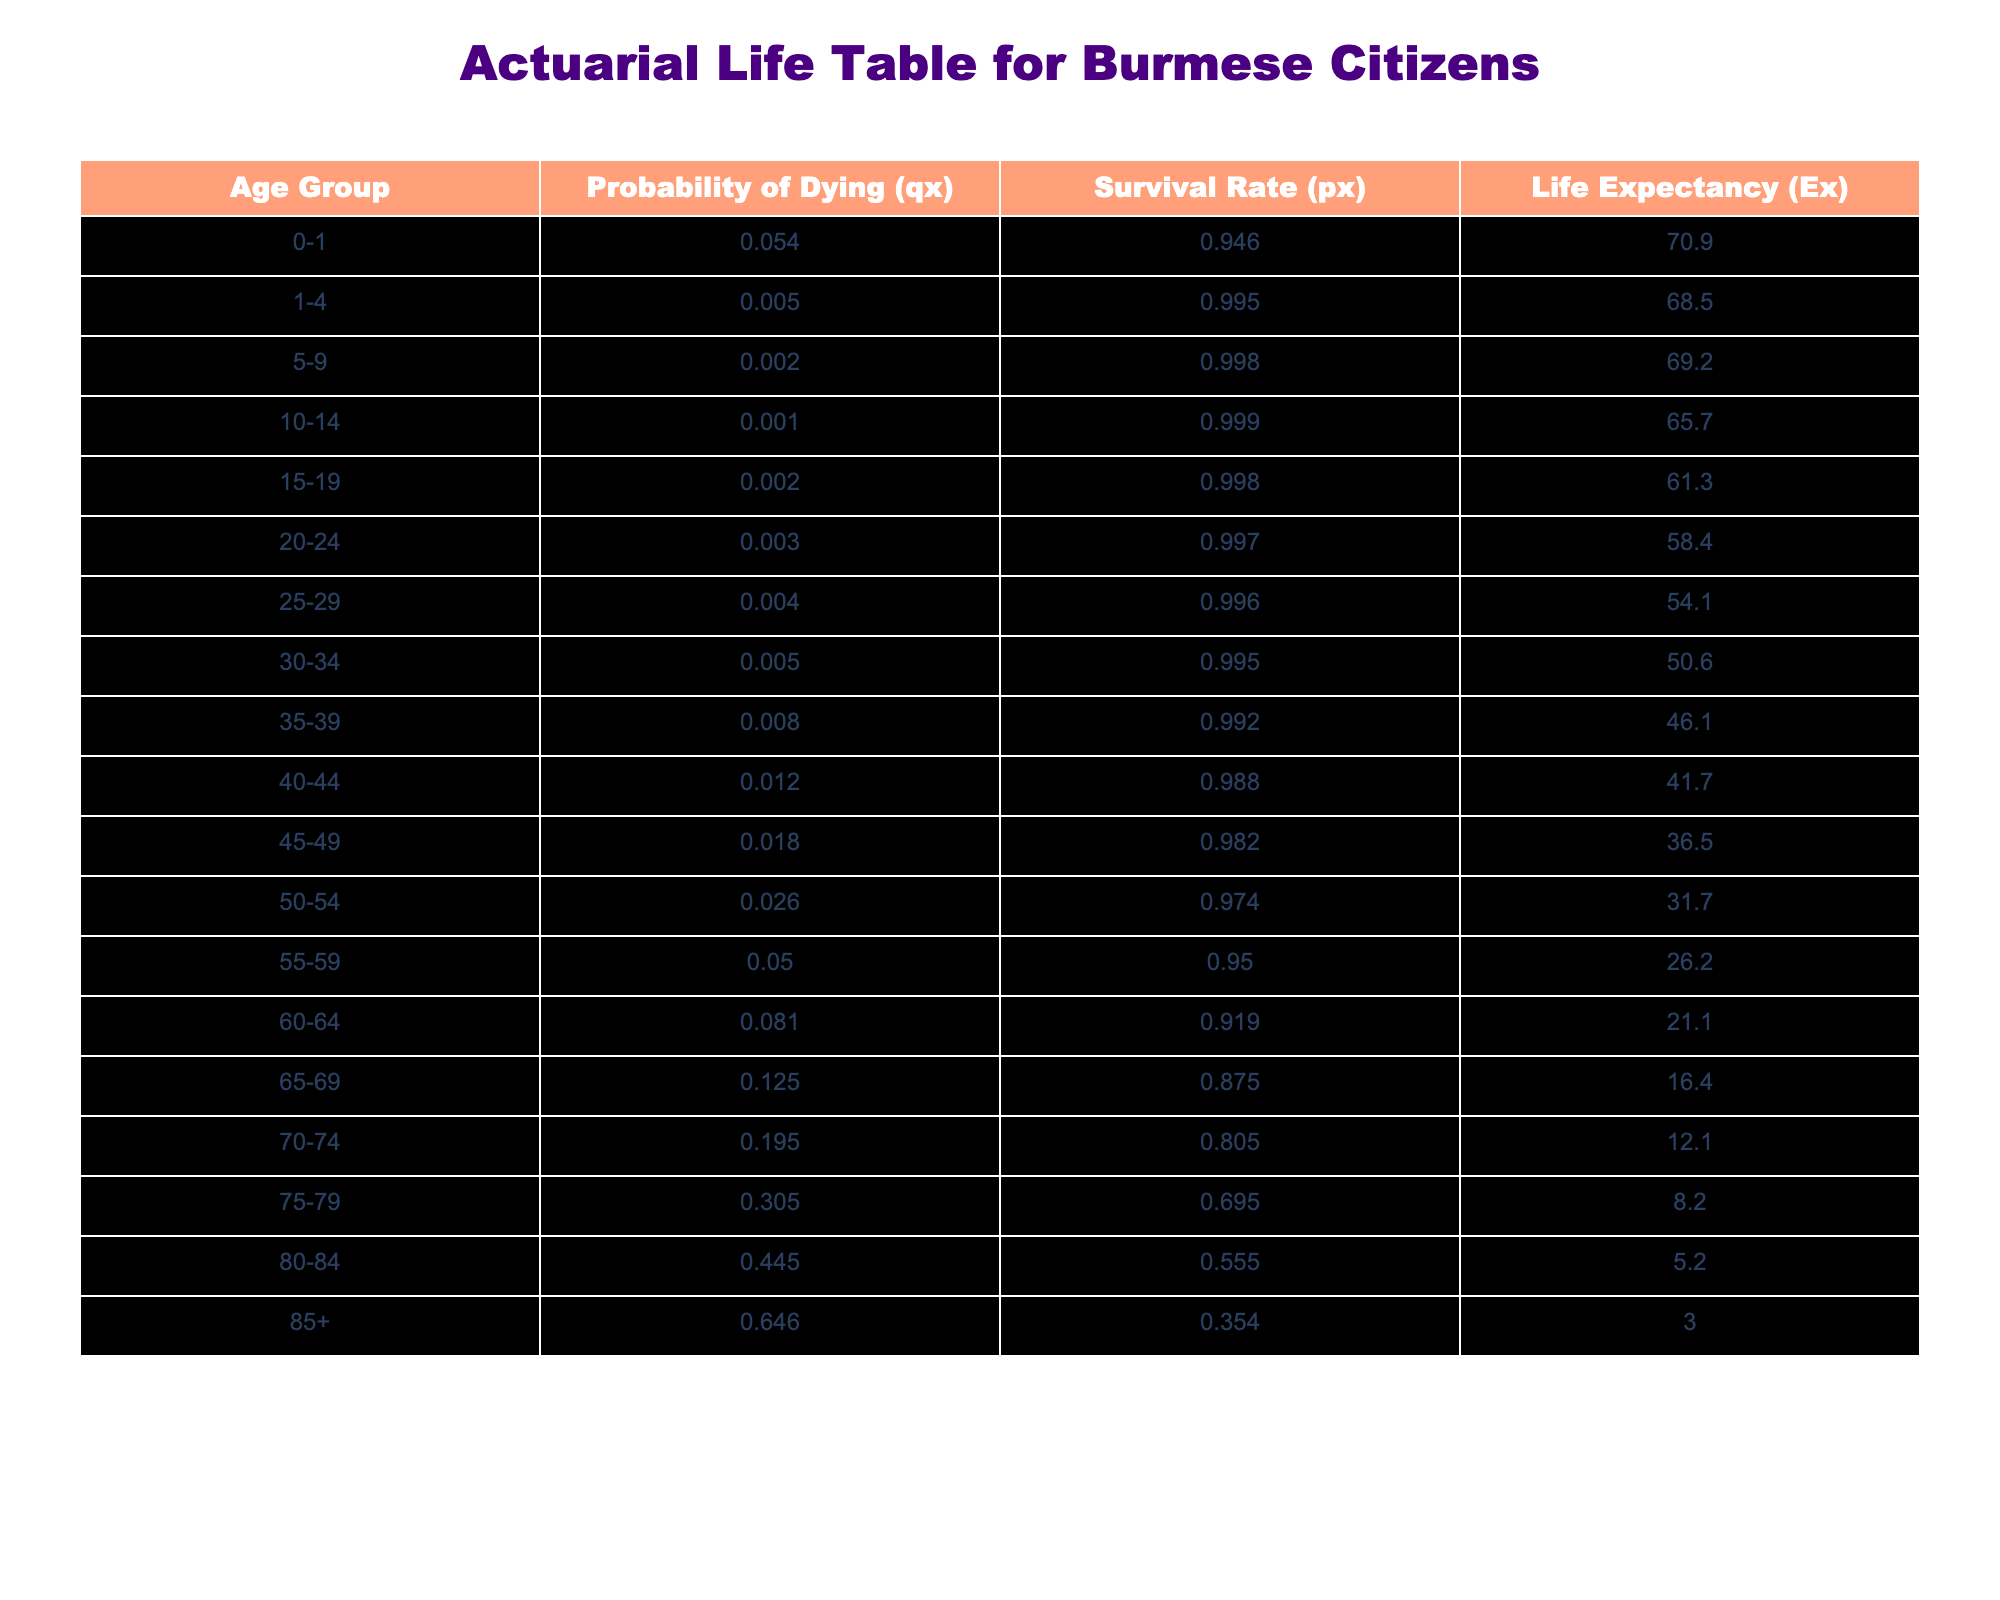What is the probability of dying for the age group 35-39? The table shows the probability of dying (qx) for the age group 35-39, which is directly listed as 0.008.
Answer: 0.008 What is the survival rate for children aged 0-1? The survival rate (px) for the age group 0-1 can be found directly in the table as 0.946.
Answer: 0.946 What is the life expectancy for an individual aged 80-84? According to the table, the life expectancy (Ex) for the age group 80-84 is given as 5.2 years.
Answer: 5.2 What is the average life expectancy for the age groups 0-1 and 1-4? To calculate the average life expectancy, we add the life expectancies for those age groups (70.9 + 68.5) = 139.4, and then divide by 2, which results in 139.4 / 2 = 69.7.
Answer: 69.7 Is the probability of dying higher for the age group 70-74 than for the age group 75-79? For age group 70-74, the probability of dying is 0.195, while for 75-79, it is 0.305. Since 0.305 is greater than 0.195, the statement is true.
Answer: Yes What is the difference in survival rates between the age groups 60-64 and 65-69? The survival rate for 60-64 is 0.919, and for 65-69 it is 0.875. To find the difference, we calculate 0.919 - 0.875 = 0.044.
Answer: 0.044 Which age group has the highest probability of dying? By examining the table, the age group 85+ has the highest probability of dying at 0.646.
Answer: 85+ What age group has a higher life expectancy: 50-54 or 55-59? The life expectancy for the age group 50-54 is 31.7 years, while for 55-59 it is 26.2 years. Since 31.7 is greater than 26.2, the 50-54 age group has a higher life expectancy.
Answer: 50-54 What is the total probability of dying for the age groups 0-1, 1-4, and 5-9? To find the total probability of dying, we sum the probabilities qx for the age groups: 0.054 + 0.005 + 0.002 = 0.061.
Answer: 0.061 What can we conclude about life expectancy trends as age increases? The table suggests that life expectancy decreases as age increases. For example, life expectancy for 0-1 is 70.9 years, while for 85+, it is only 3.0 years.
Answer: Life expectancy decreases with age 